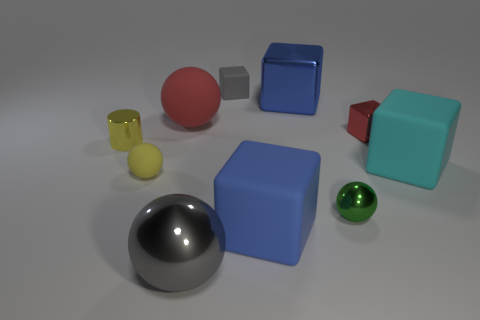Subtract 1 balls. How many balls are left? 3 Subtract all red cubes. How many cubes are left? 4 Subtract all tiny matte cubes. How many cubes are left? 4 Subtract all brown blocks. Subtract all green cylinders. How many blocks are left? 5 Subtract all cylinders. How many objects are left? 9 Subtract all brown rubber cubes. Subtract all blocks. How many objects are left? 5 Add 4 rubber balls. How many rubber balls are left? 6 Add 5 rubber things. How many rubber things exist? 10 Subtract 0 blue cylinders. How many objects are left? 10 